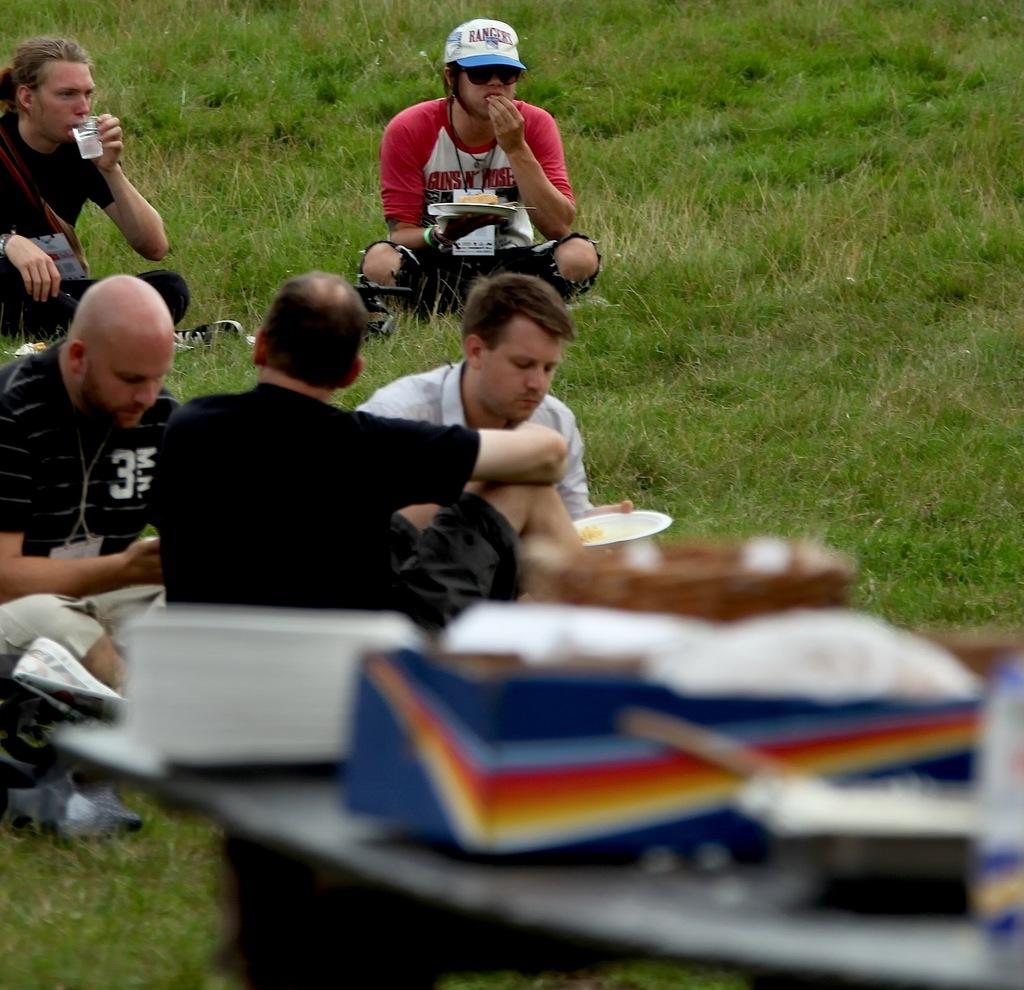What are the people in the image doing? The people in the image are sitting. What are the people wearing? The people are wearing clothes. Can you describe any specific accessories worn by the people? One person is wearing goggles, and another person is wearing a cap. What type of environment can be seen in the image? There is grass visible in the image. What object is being held by one of the people? One person is holding a glass. What type of potato is being used as a rake in the image? There is no potato or rake present in the image. Is there a beggar visible in the image? No, there is no beggar visible in the image. 